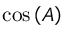<formula> <loc_0><loc_0><loc_500><loc_500>\cos \left ( A \right )</formula> 